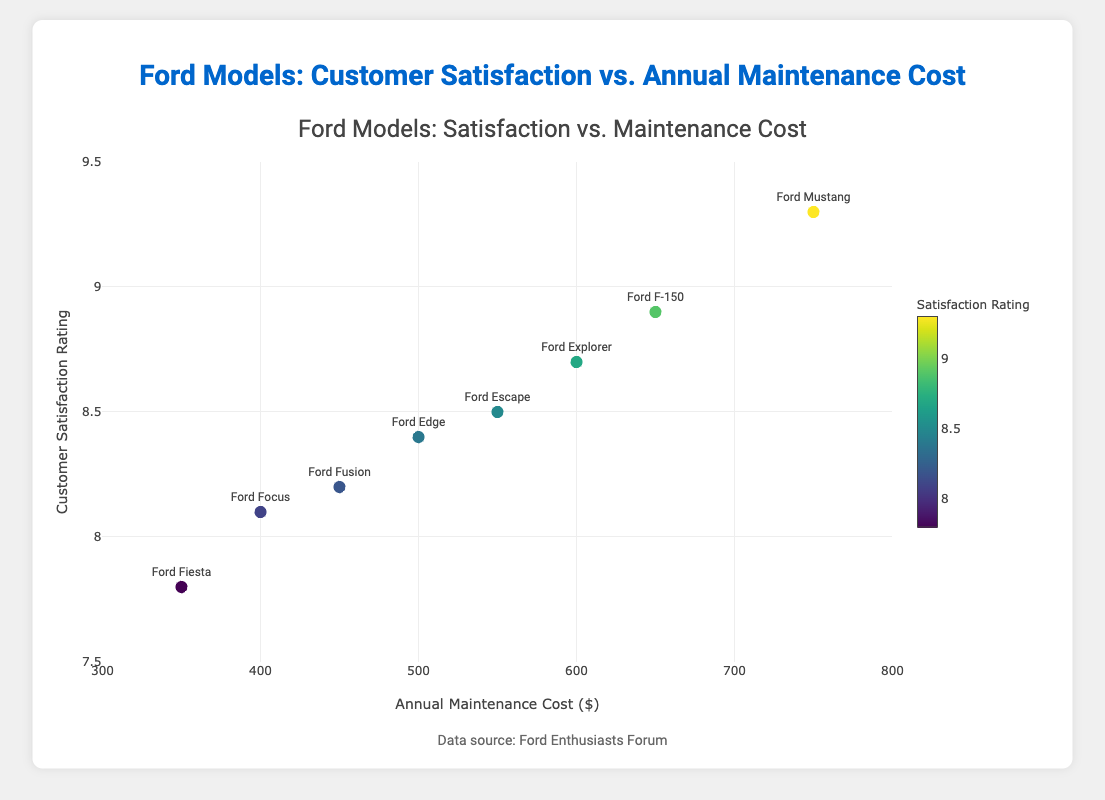What is the title of the scatter plot? The title is displayed at the top of the scatter plot.
Answer: Ford Models: Satisfaction vs. Maintenance Cost What is the range of the y-axis? The range of the y-axis can be seen on the left side of the plot, running vertically from the lowest to the highest value.
Answer: [7.5, 9.5] Which Ford model has the highest customer satisfaction rating? By looking at the plotted points, the highest satisfaction rating (9.3) is labeled with "Ford Mustang".
Answer: Ford Mustang Which model has the lowest annual maintenance cost, and what is the customer's satisfaction rating for that model? Identify the point with the lowest x-value (350) and read its y-value and label. The label is "Ford Fiesta", and the y-value (satisfaction rating) is 7.8.
Answer: Ford Fiesta, 7.8 Between the Ford F-150 and Ford Explorer, which one has a higher customer satisfaction rating and what is the difference? Compare the y-values of the two labeled points: Ford F-150 has a rating of 8.9 and Ford Explorer has a rating of 8.7. The difference is 8.9 - 8.7.
Answer: Ford F-150, 0.2 What is the average annual maintenance cost for all the Ford models in the plot? Sum up all the maintenance costs and divide by the number of models: (400 + 350 + 750 + 600 + 550 + 650 + 500 + 450) / 8. The total cost is 4250, so 4250 / 8.
Answer: 531.25 Is there a positive correlation between customer satisfaction rating and annual maintenance cost? From the scatter plot, observe the trend of the data points. As maintenance cost increases, satisfaction rating tends to increase, indicating a positive correlation.
Answer: Yes How many data points are shown in the scatter plot? Count the number of markers plotted on the graph, each representing a Ford model.
Answer: 8 Which model has both a high customer satisfaction rating and a relatively low annual maintenance cost? Look for a model that combines a high y-value with a mid-to-low x-value. Ford Focus (8.1 rating, $400 cost) and Ford Fusion (8.2 rating, $450 cost) are good fits, Ford Escape (8.5 rating, $550 cost)is the best fit considering high satisfaction.
Answer: Ford Escape What's the difference in annual maintenance cost between the Ford Focus and Ford Mustang, and how do their satisfaction ratings compare? Subtract Focus' maintenance cost from Mustang's: 750 - 400 = 350. Compare their ratings: Mustang 9.3, Focus 8.1. Mustang has a higher rating with a larger maintenance cost difference.
Answer: 350, Mustang has higher satisfaction 